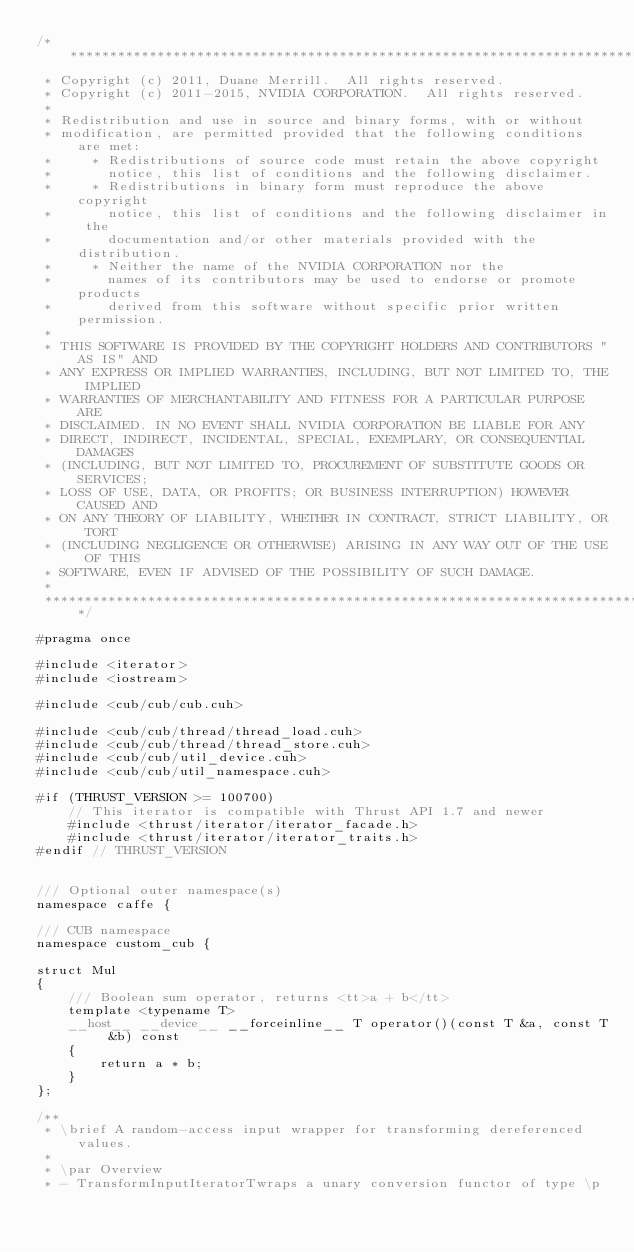Convert code to text. <code><loc_0><loc_0><loc_500><loc_500><_Cuda_>/******************************************************************************
 * Copyright (c) 2011, Duane Merrill.  All rights reserved.
 * Copyright (c) 2011-2015, NVIDIA CORPORATION.  All rights reserved.
 * 
 * Redistribution and use in source and binary forms, with or without
 * modification, are permitted provided that the following conditions are met:
 *     * Redistributions of source code must retain the above copyright
 *       notice, this list of conditions and the following disclaimer.
 *     * Redistributions in binary form must reproduce the above copyright
 *       notice, this list of conditions and the following disclaimer in the
 *       documentation and/or other materials provided with the distribution.
 *     * Neither the name of the NVIDIA CORPORATION nor the
 *       names of its contributors may be used to endorse or promote products
 *       derived from this software without specific prior written permission.
 * 
 * THIS SOFTWARE IS PROVIDED BY THE COPYRIGHT HOLDERS AND CONTRIBUTORS "AS IS" AND
 * ANY EXPRESS OR IMPLIED WARRANTIES, INCLUDING, BUT NOT LIMITED TO, THE IMPLIED
 * WARRANTIES OF MERCHANTABILITY AND FITNESS FOR A PARTICULAR PURPOSE ARE
 * DISCLAIMED. IN NO EVENT SHALL NVIDIA CORPORATION BE LIABLE FOR ANY
 * DIRECT, INDIRECT, INCIDENTAL, SPECIAL, EXEMPLARY, OR CONSEQUENTIAL DAMAGES
 * (INCLUDING, BUT NOT LIMITED TO, PROCUREMENT OF SUBSTITUTE GOODS OR SERVICES;
 * LOSS OF USE, DATA, OR PROFITS; OR BUSINESS INTERRUPTION) HOWEVER CAUSED AND
 * ON ANY THEORY OF LIABILITY, WHETHER IN CONTRACT, STRICT LIABILITY, OR TORT
 * (INCLUDING NEGLIGENCE OR OTHERWISE) ARISING IN ANY WAY OUT OF THE USE OF THIS
 * SOFTWARE, EVEN IF ADVISED OF THE POSSIBILITY OF SUCH DAMAGE.
 *
 ******************************************************************************/

#pragma once

#include <iterator>
#include <iostream>

#include <cub/cub/cub.cuh>

#include <cub/cub/thread/thread_load.cuh>
#include <cub/cub/thread/thread_store.cuh>
#include <cub/cub/util_device.cuh>
#include <cub/cub/util_namespace.cuh>

#if (THRUST_VERSION >= 100700)
    // This iterator is compatible with Thrust API 1.7 and newer
    #include <thrust/iterator/iterator_facade.h>
    #include <thrust/iterator/iterator_traits.h>
#endif // THRUST_VERSION


/// Optional outer namespace(s)
namespace caffe {

/// CUB namespace
namespace custom_cub {

struct Mul
{
    /// Boolean sum operator, returns <tt>a + b</tt>
    template <typename T>
    __host__ __device__ __forceinline__ T operator()(const T &a, const T &b) const
    {
        return a * b;
    }
};

/**
 * \brief A random-access input wrapper for transforming dereferenced values.
 *
 * \par Overview
 * - TransformInputIteratorTwraps a unary conversion functor of type \p</code> 